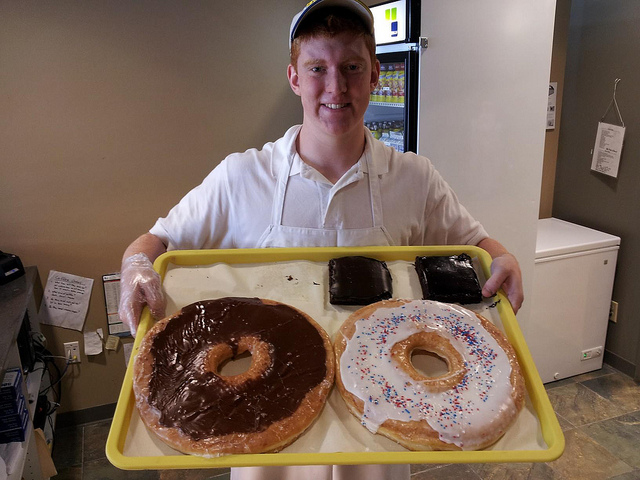Can you tell me what the person is doing with these unusually large pastries? The person is proudly displaying the giant pastries, possibly as a promotional product or as part of a special event highlighting unique and oversized baked goods. What kind of event might feature these pastries? Such oversized items are often featured at food festivals, marketing events, or celebrations at bakeries to draw attention and showcase baking creativity and skill. 